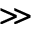<formula> <loc_0><loc_0><loc_500><loc_500>\gg</formula> 